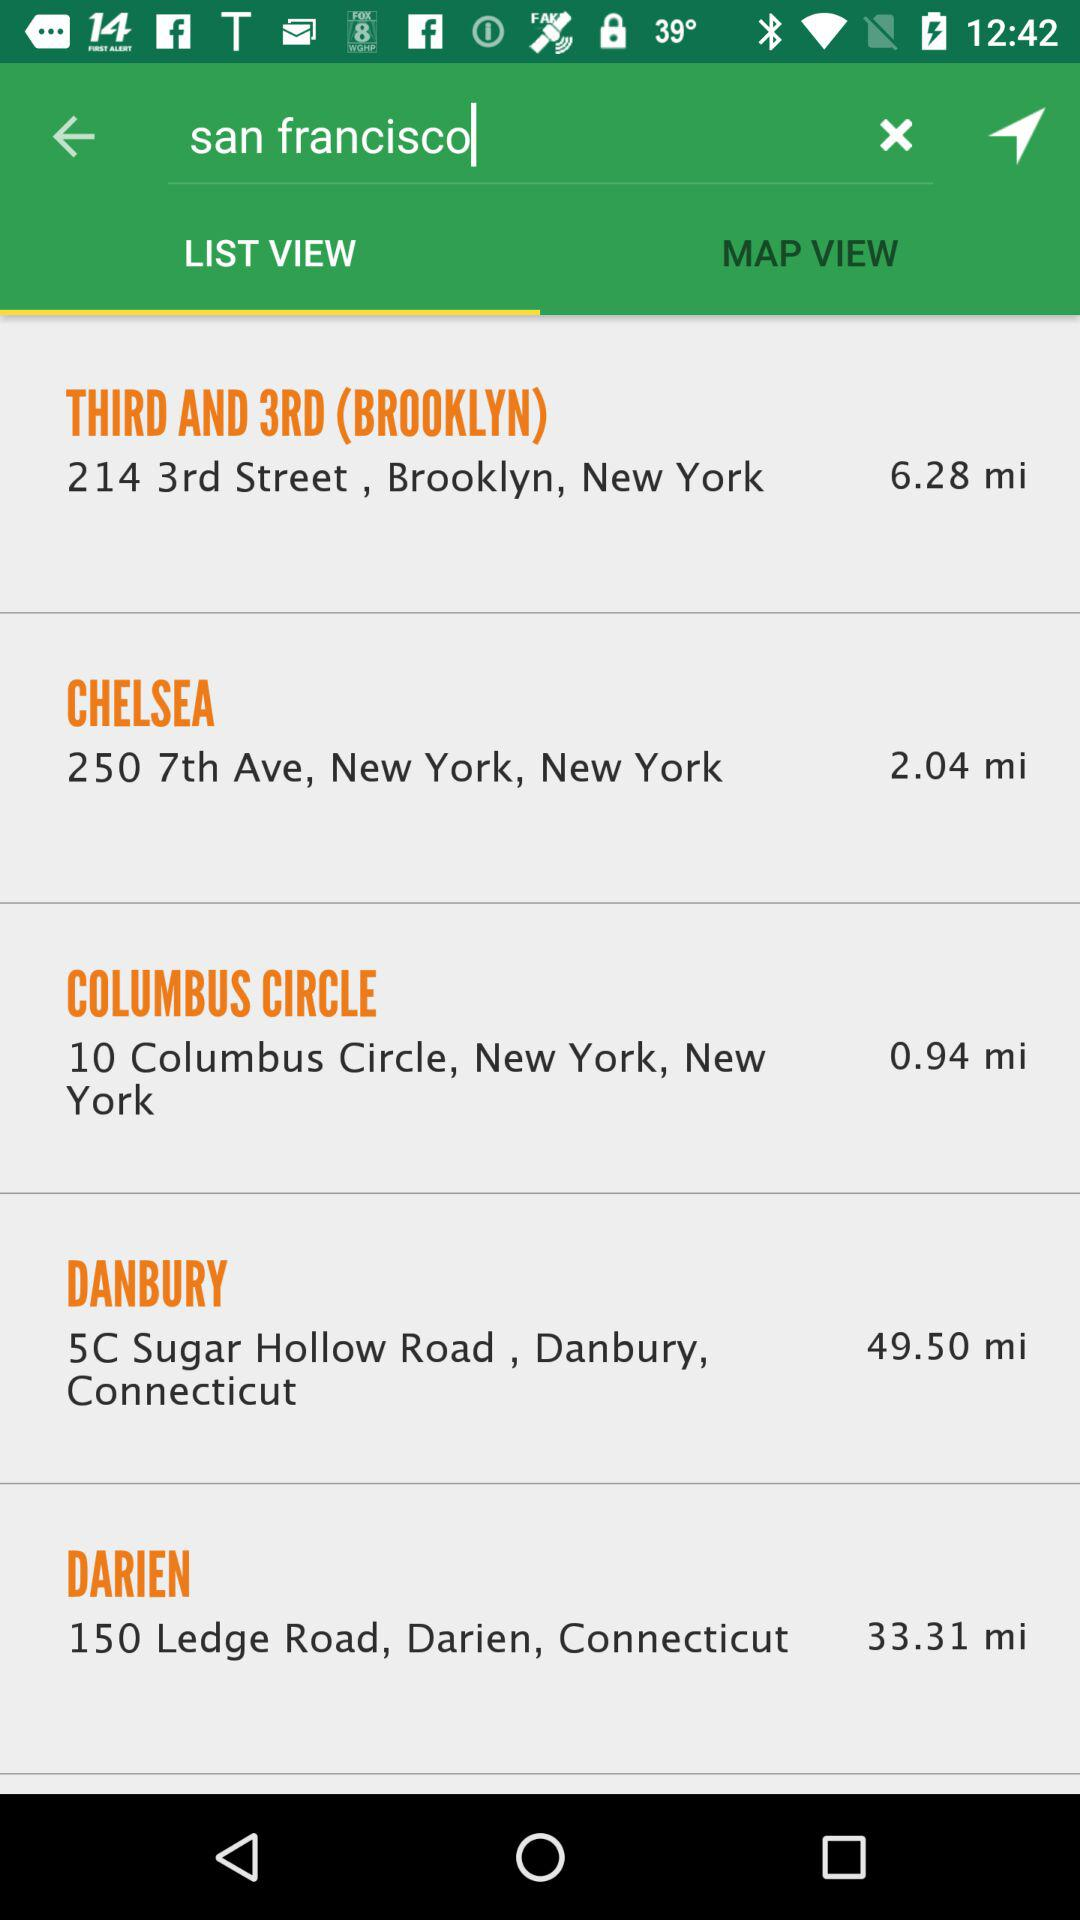What is the address of Columbus Circle? The address is 10 Columbus Circle, New York, New York. 